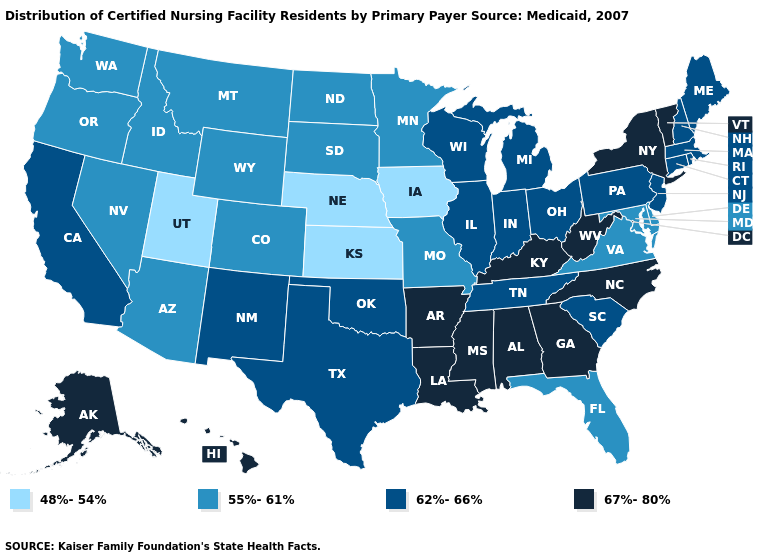Name the states that have a value in the range 62%-66%?
Quick response, please. California, Connecticut, Illinois, Indiana, Maine, Massachusetts, Michigan, New Hampshire, New Jersey, New Mexico, Ohio, Oklahoma, Pennsylvania, Rhode Island, South Carolina, Tennessee, Texas, Wisconsin. Among the states that border Tennessee , which have the lowest value?
Concise answer only. Missouri, Virginia. Does Iowa have the lowest value in the MidWest?
Concise answer only. Yes. What is the value of Florida?
Write a very short answer. 55%-61%. Among the states that border Kentucky , does Missouri have the lowest value?
Keep it brief. Yes. Does North Carolina have the highest value in the USA?
Give a very brief answer. Yes. What is the value of New Mexico?
Write a very short answer. 62%-66%. Does the first symbol in the legend represent the smallest category?
Keep it brief. Yes. Is the legend a continuous bar?
Short answer required. No. Does the map have missing data?
Keep it brief. No. Which states have the lowest value in the South?
Short answer required. Delaware, Florida, Maryland, Virginia. Does Vermont have the lowest value in the Northeast?
Answer briefly. No. Does Ohio have a lower value than Nebraska?
Quick response, please. No. Name the states that have a value in the range 62%-66%?
Give a very brief answer. California, Connecticut, Illinois, Indiana, Maine, Massachusetts, Michigan, New Hampshire, New Jersey, New Mexico, Ohio, Oklahoma, Pennsylvania, Rhode Island, South Carolina, Tennessee, Texas, Wisconsin. Name the states that have a value in the range 55%-61%?
Write a very short answer. Arizona, Colorado, Delaware, Florida, Idaho, Maryland, Minnesota, Missouri, Montana, Nevada, North Dakota, Oregon, South Dakota, Virginia, Washington, Wyoming. 